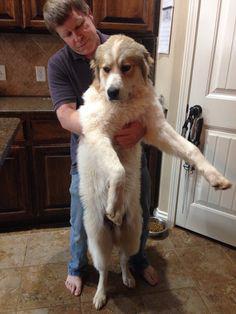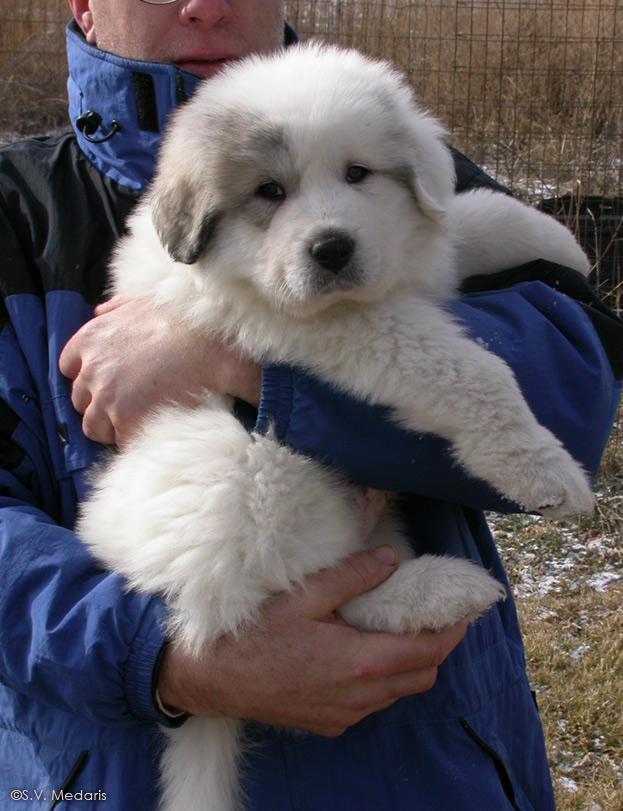The first image is the image on the left, the second image is the image on the right. Analyze the images presented: Is the assertion "There are exactly four dogs." valid? Answer yes or no. No. The first image is the image on the left, the second image is the image on the right. Examine the images to the left and right. Is the description "The combined images contain a total of four dogs, including a row of three dogs posed side-by-side." accurate? Answer yes or no. No. 